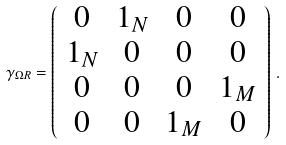Convert formula to latex. <formula><loc_0><loc_0><loc_500><loc_500>\gamma _ { \Omega R } = \left ( \begin{array} { c c c c } 0 & 1 _ { N } & 0 & 0 \\ 1 _ { N } & 0 & 0 & 0 \\ 0 & 0 & 0 & 1 _ { M } \\ 0 & 0 & 1 _ { M } & 0 \\ \end{array} \right ) \, .</formula> 